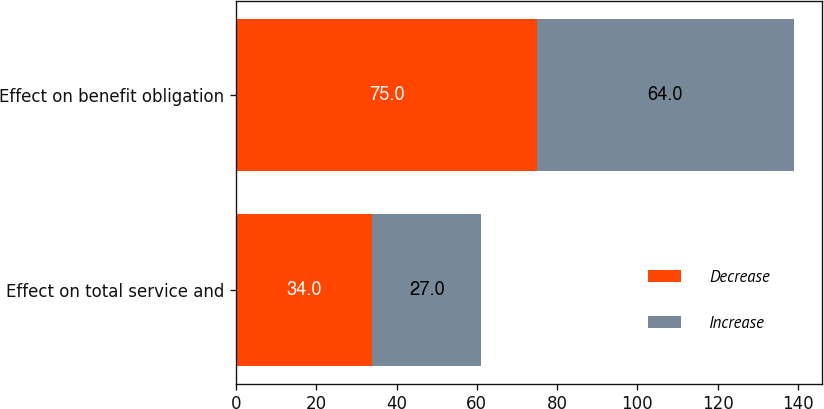Convert chart to OTSL. <chart><loc_0><loc_0><loc_500><loc_500><stacked_bar_chart><ecel><fcel>Effect on total service and<fcel>Effect on benefit obligation<nl><fcel>Decrease<fcel>34<fcel>75<nl><fcel>Increase<fcel>27<fcel>64<nl></chart> 